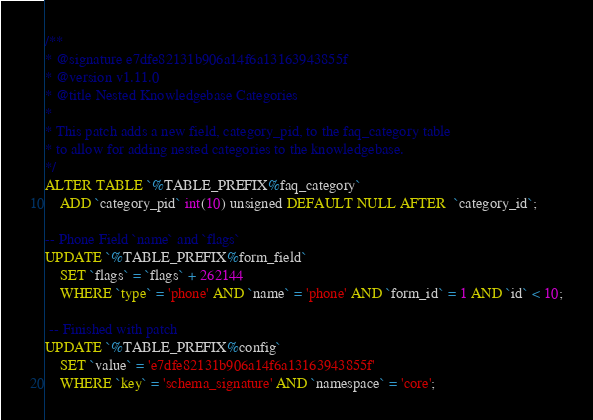<code> <loc_0><loc_0><loc_500><loc_500><_SQL_>/**
* @signature e7dfe82131b906a14f6a13163943855f
* @version v1.11.0
* @title Nested Knowledgebase Categories
*
* This patch adds a new field, category_pid, to the faq_category table
* to allow for adding nested categories to the knowledgebase.
*/
ALTER TABLE `%TABLE_PREFIX%faq_category`
    ADD `category_pid` int(10) unsigned DEFAULT NULL AFTER  `category_id`;

-- Phone Field `name` and `flags`
UPDATE `%TABLE_PREFIX%form_field`
    SET `flags` = `flags` + 262144
    WHERE `type` = 'phone' AND `name` = 'phone' AND `form_id` = 1 AND `id` < 10;

 -- Finished with patch
UPDATE `%TABLE_PREFIX%config`
    SET `value` = 'e7dfe82131b906a14f6a13163943855f'
    WHERE `key` = 'schema_signature' AND `namespace` = 'core';
</code> 